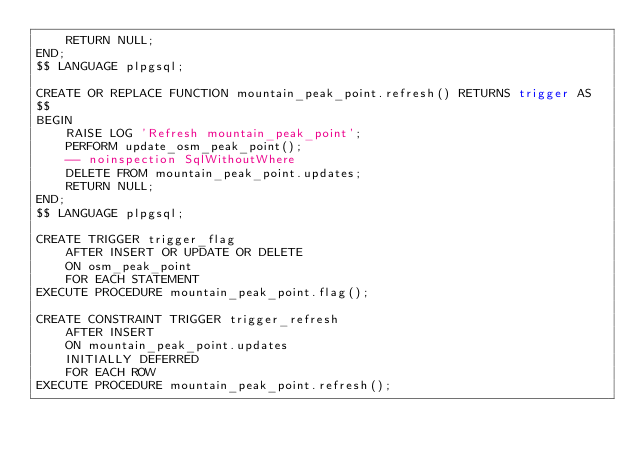<code> <loc_0><loc_0><loc_500><loc_500><_SQL_>    RETURN NULL;
END;
$$ LANGUAGE plpgsql;

CREATE OR REPLACE FUNCTION mountain_peak_point.refresh() RETURNS trigger AS
$$
BEGIN
    RAISE LOG 'Refresh mountain_peak_point';
    PERFORM update_osm_peak_point();
    -- noinspection SqlWithoutWhere
    DELETE FROM mountain_peak_point.updates;
    RETURN NULL;
END;
$$ LANGUAGE plpgsql;

CREATE TRIGGER trigger_flag
    AFTER INSERT OR UPDATE OR DELETE
    ON osm_peak_point
    FOR EACH STATEMENT
EXECUTE PROCEDURE mountain_peak_point.flag();

CREATE CONSTRAINT TRIGGER trigger_refresh
    AFTER INSERT
    ON mountain_peak_point.updates
    INITIALLY DEFERRED
    FOR EACH ROW
EXECUTE PROCEDURE mountain_peak_point.refresh();
</code> 